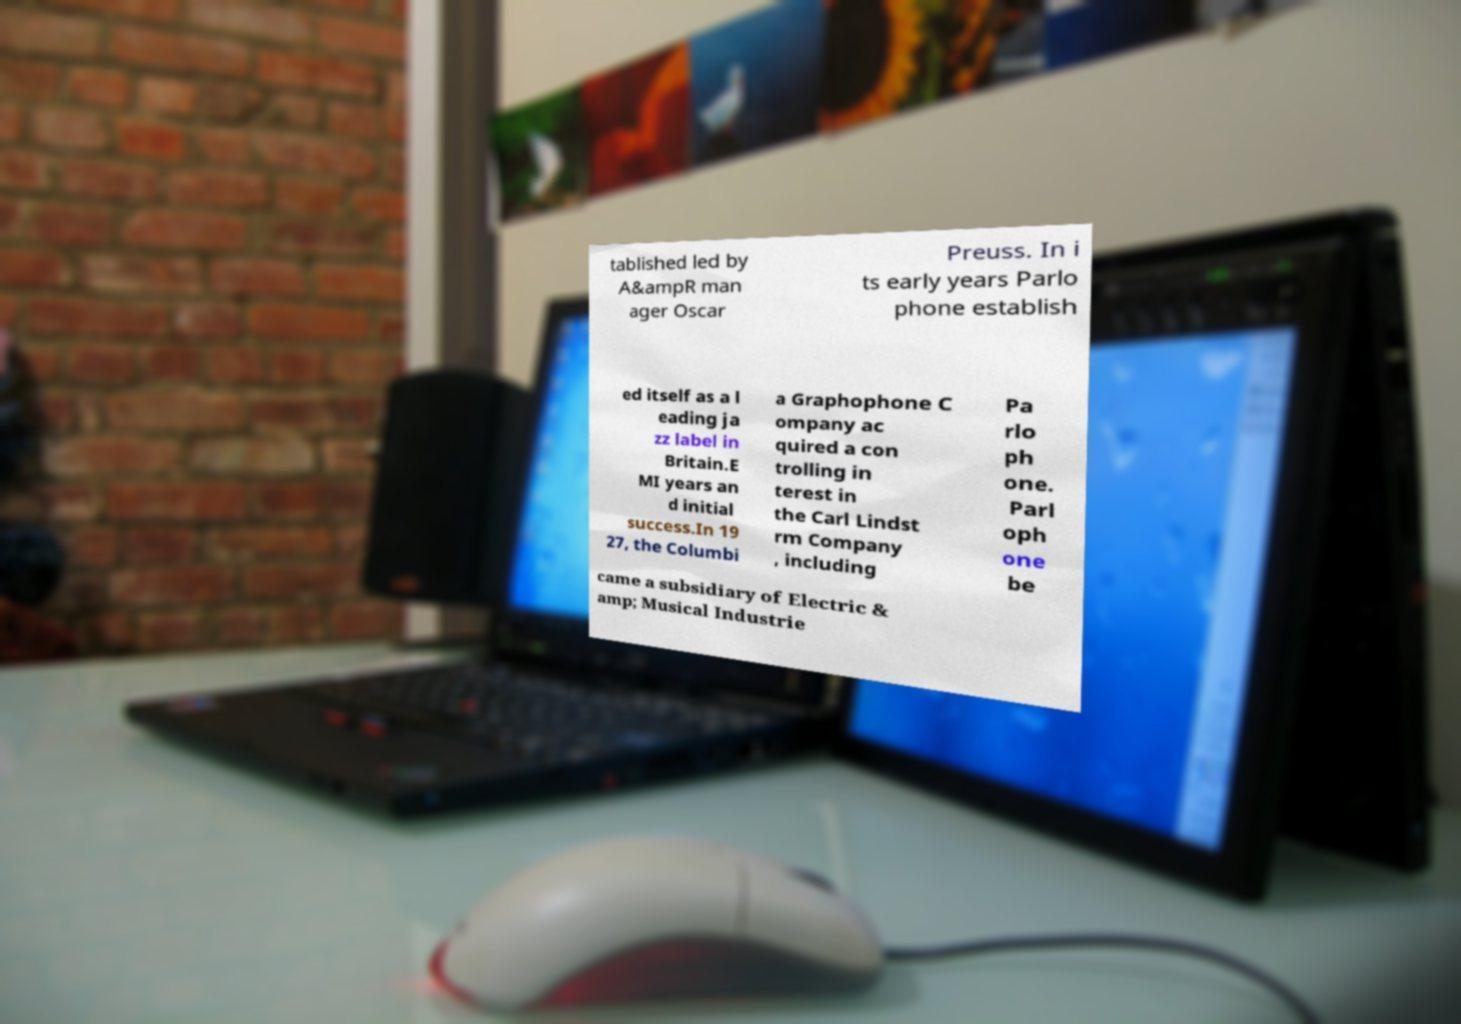I need the written content from this picture converted into text. Can you do that? tablished led by A&ampR man ager Oscar Preuss. In i ts early years Parlo phone establish ed itself as a l eading ja zz label in Britain.E MI years an d initial success.In 19 27, the Columbi a Graphophone C ompany ac quired a con trolling in terest in the Carl Lindst rm Company , including Pa rlo ph one. Parl oph one be came a subsidiary of Electric & amp; Musical Industrie 